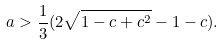Convert formula to latex. <formula><loc_0><loc_0><loc_500><loc_500>a > \frac { 1 } { 3 } ( 2 \sqrt { 1 - c + c ^ { 2 } } - 1 - c ) .</formula> 